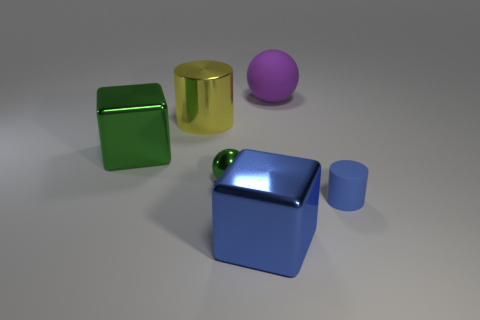What could be the possible real-world sizes of these objects if they were to scale with each other? If these objects were to scale with each other, the green square could represent a cube with edges possibly around 10 centimeters, common for a small decorative object or toy block. The golden cylinder may be akin to a standard-sized cup or container, around 12 centimeters tall. The purple sphere might be the size of a small ball, approximately 8 centimeters in diameter, similar to a stress ball. The blue cube looks to be the largest and might measure roughly 15 centimeters on each side, resembling the size of a medium-sized storage box. The small matte cylinder is similar to the size of a piece from a children's building block set, possibly around 5 centimeters tall. 